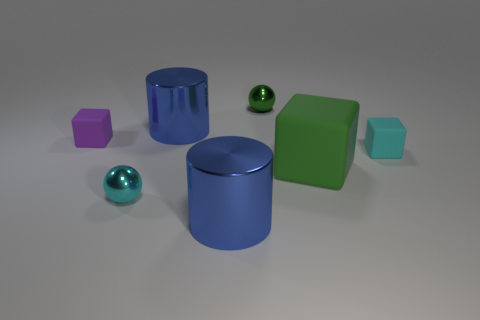Subtract all large cubes. How many cubes are left? 2 Add 3 big red metal blocks. How many objects exist? 10 Subtract all cyan cubes. How many cubes are left? 2 Subtract all cylinders. How many objects are left? 5 Add 4 large green things. How many large green things exist? 5 Subtract 0 green cylinders. How many objects are left? 7 Subtract 2 spheres. How many spheres are left? 0 Subtract all yellow blocks. Subtract all green cylinders. How many blocks are left? 3 Subtract all yellow cubes. How many red balls are left? 0 Subtract all blue shiny cylinders. Subtract all green objects. How many objects are left? 3 